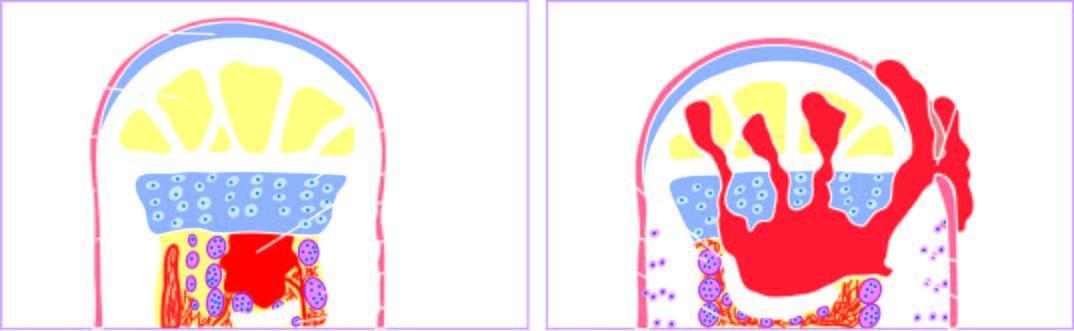s the cyst wall beginning of reactive woven bone formation by the periosteum?
Answer the question using a single word or phrase. No 